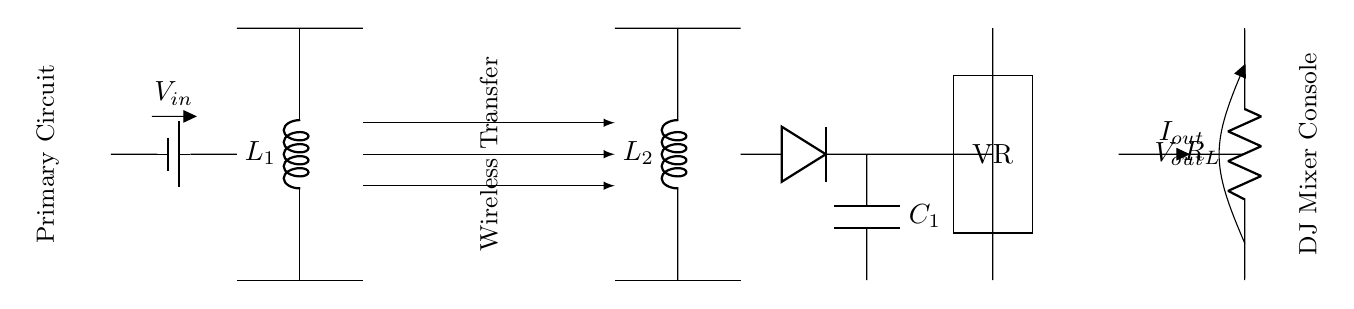What is the input voltage in this circuit? The input voltage is represented by the battery labeled as \( V_{in} \), which is shown on the left side of the circuit.
Answer: V in What are the two main inductors in the circuit? The main inductors in the circuit are labeled \( L_1 \) and \( L_2 \), which are part of the primary and secondary coils respectively.
Answer: L 1, L 2 What is the role of the rectifier in this circuit? The rectifier, represented by the diode, converts alternating current from the secondary coil into direct current for use in the DJ mixer console.
Answer: Convert AC to DC How does power transfer occur in this circuit? Power transfer occurs wirelessly through the inductive coupling between the primary coil \( L_1 \) and the secondary coil \( L_2 \), as indicated by the arrows showing the direction of power flow between them.
Answer: Inductive coupling What is the purpose of the voltage regulator in this circuit? The voltage regulator, labeled as VR, maintains a consistent output voltage regardless of variations in input voltage or load conditions.
Answer: Maintain output voltage What is the output current defined as in this circuit? The output current is denoted by \( I_{out} \), shown flowing out from the voltage regulator towards the load \( R_L \) connected to the DJ mixer console.
Answer: I out What component is used to filter the output voltage? The capacitor labeled \( C_1 \) is used to filter the output voltage by smoothing out fluctuations in the direct current supplied to the DJ mixer console.
Answer: C 1 